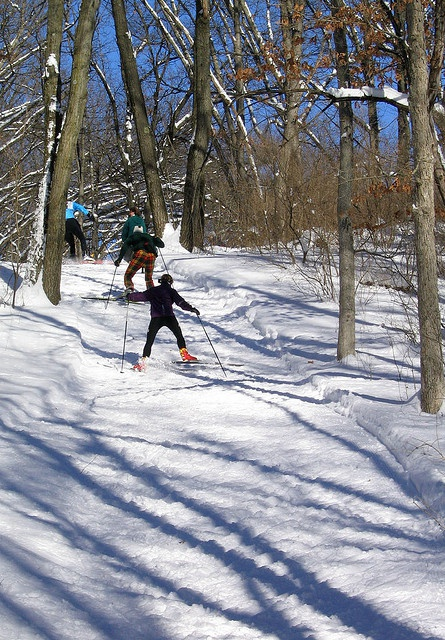Describe the objects in this image and their specific colors. I can see people in gray, black, and purple tones, people in gray, black, and maroon tones, people in gray, black, lightgray, and darkgray tones, people in gray, black, teal, and maroon tones, and skis in gray, lightgray, darkgray, and black tones in this image. 